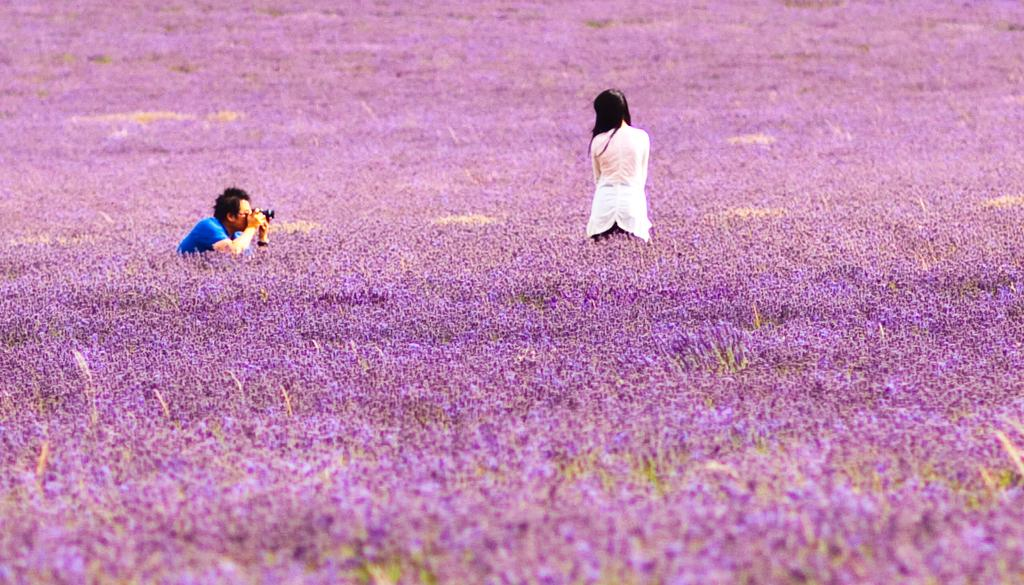How many people are in the image? There are two persons standing in the image. What is one of the persons holding in his hand? One person is holding a camera in his hand. What can be seen in the background of the image? There are flowers visible in the background of the image. How many children are playing in the background of the image? There are no children present in the image; it only features two adults and flowers in the background. Is the person holding the camera a beginner photographer? We cannot determine the person's level of expertise from the image alone, as there is no information provided about their photography skills. 